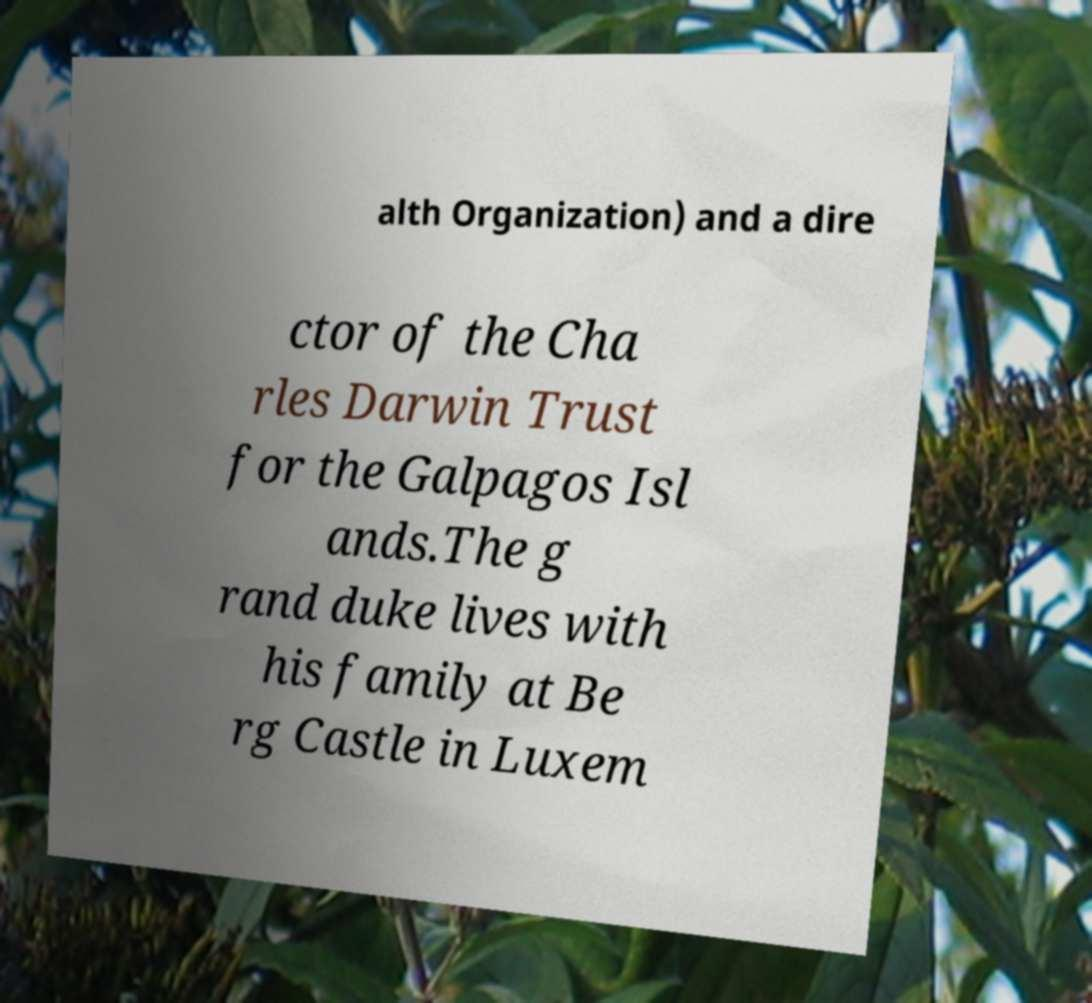I need the written content from this picture converted into text. Can you do that? alth Organization) and a dire ctor of the Cha rles Darwin Trust for the Galpagos Isl ands.The g rand duke lives with his family at Be rg Castle in Luxem 